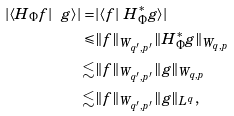<formula> <loc_0><loc_0><loc_500><loc_500>| \langle H _ { \Phi } f | \ g \rangle | = & | \langle f | \ H _ { \Phi } ^ { * } g \rangle | \\ \leqslant & \| f \| _ { W _ { q ^ { \prime } , p ^ { \prime } } } \| H _ { \Phi } ^ { * } g \| _ { W _ { q , p } } \\ \lesssim & \| f \| _ { W _ { q ^ { \prime } , p ^ { \prime } } } \| g \| _ { W _ { q , p } } \\ \lesssim & \| f \| _ { W _ { q ^ { \prime } , p ^ { \prime } } } \| g \| _ { L ^ { q } } ,</formula> 